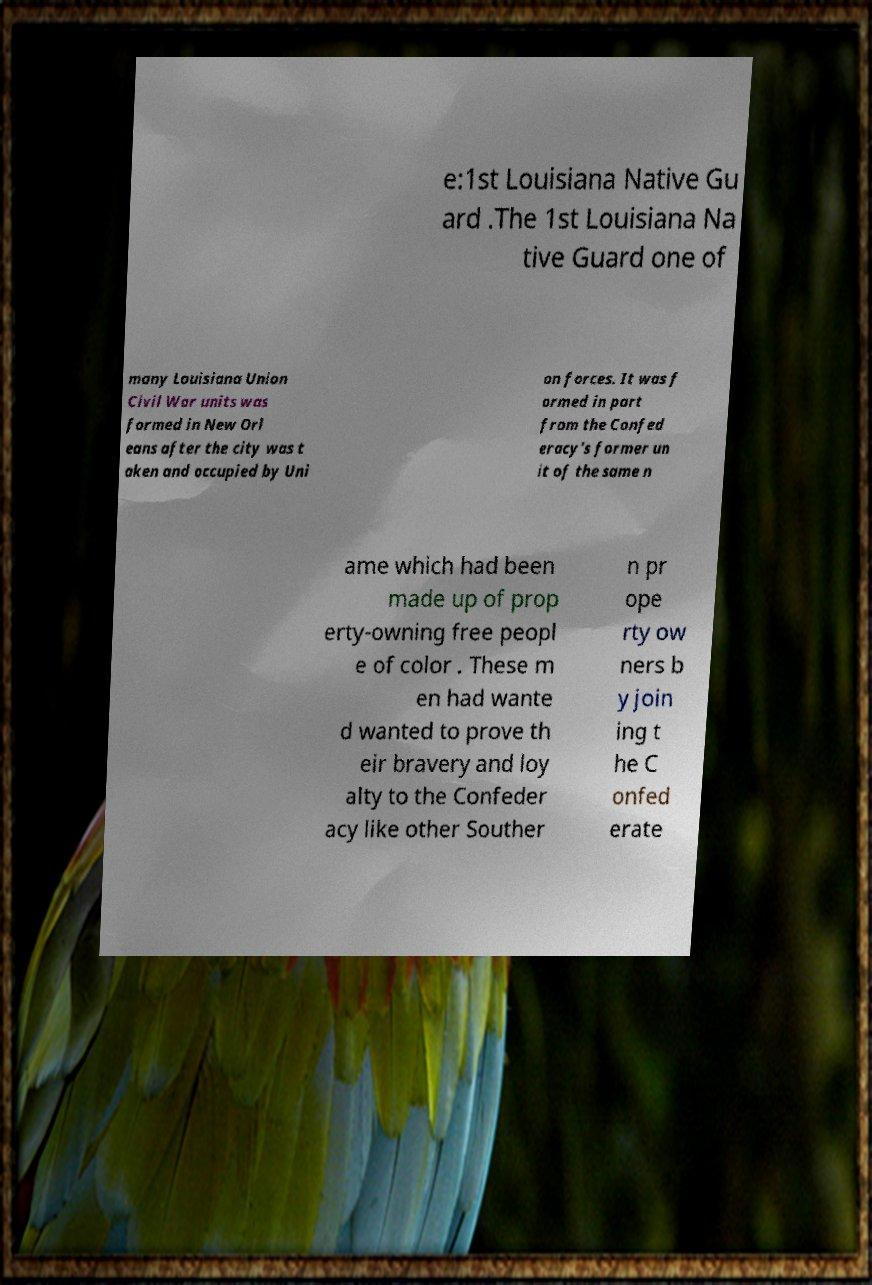I need the written content from this picture converted into text. Can you do that? e:1st Louisiana Native Gu ard .The 1st Louisiana Na tive Guard one of many Louisiana Union Civil War units was formed in New Orl eans after the city was t aken and occupied by Uni on forces. It was f ormed in part from the Confed eracy's former un it of the same n ame which had been made up of prop erty-owning free peopl e of color . These m en had wante d wanted to prove th eir bravery and loy alty to the Confeder acy like other Souther n pr ope rty ow ners b y join ing t he C onfed erate 